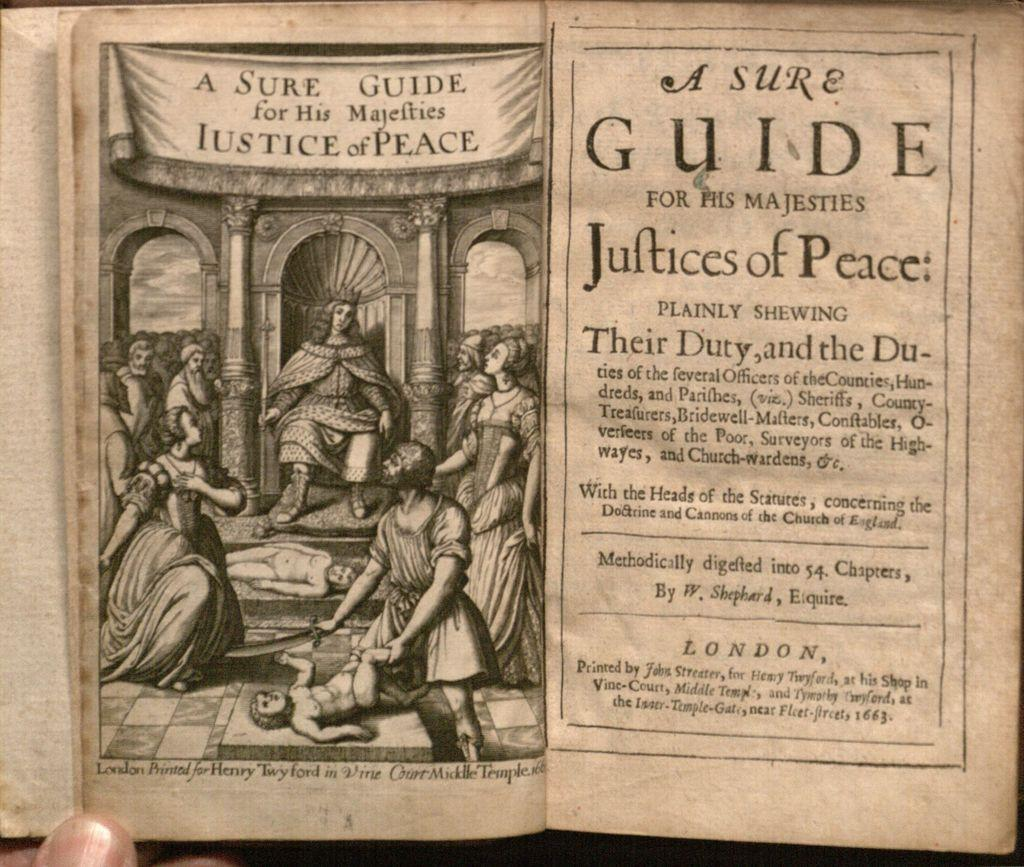What is the person in the image holding? The person is holding a book in the image. What else can be seen in the image besides the person and the book? There is there a paper with print in the image. What is depicted on the print of the paper? The print on the paper depicts people. Is there any text or writing on the paper? Yes, something is written on the paper. What type of cloth is draped over the sofa in the image? There is no sofa or cloth present in the image. 